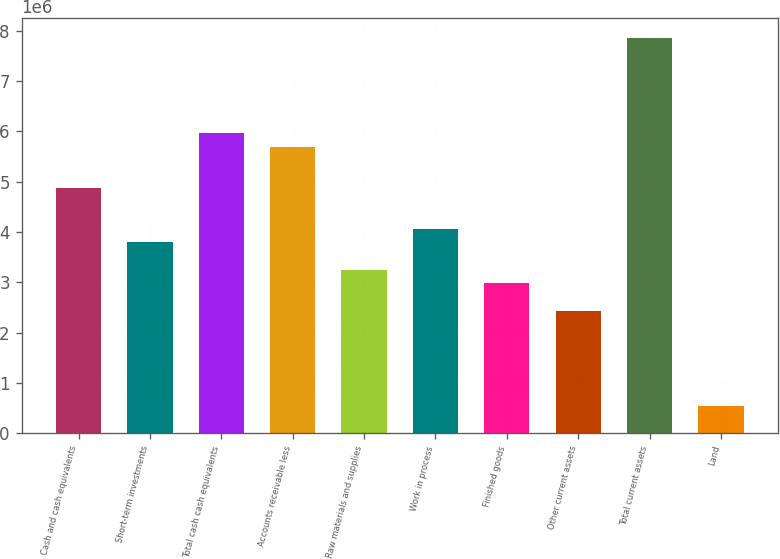Convert chart. <chart><loc_0><loc_0><loc_500><loc_500><bar_chart><fcel>Cash and cash equivalents<fcel>Short-term investments<fcel>Total cash cash equivalents<fcel>Accounts receivable less<fcel>Raw materials and supplies<fcel>Work in process<fcel>Finished goods<fcel>Other current assets<fcel>Total current assets<fcel>Land<nl><fcel>4.87232e+06<fcel>3.78962e+06<fcel>5.95502e+06<fcel>5.68435e+06<fcel>3.24827e+06<fcel>4.06029e+06<fcel>2.97759e+06<fcel>2.43624e+06<fcel>7.84975e+06<fcel>541511<nl></chart> 